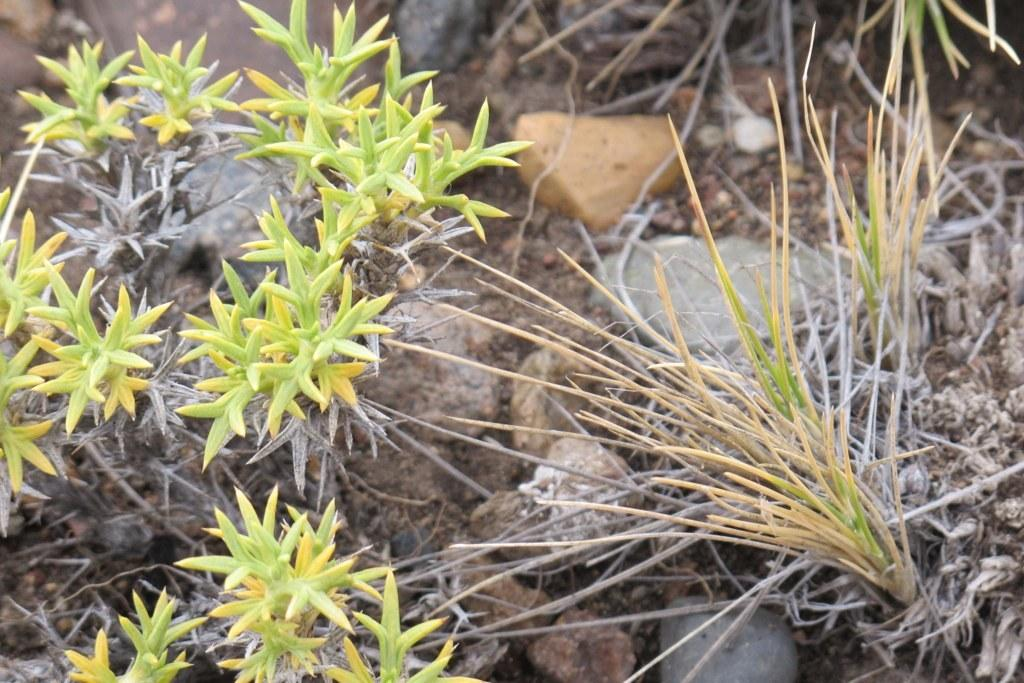What type of living organisms can be seen in the image? Plants can be seen in the image. What other objects are present in the image besides plants? There are stones in the image. Can you see a mitten on any of the plants in the image? There is no mitten present on any of the plants in the image. 